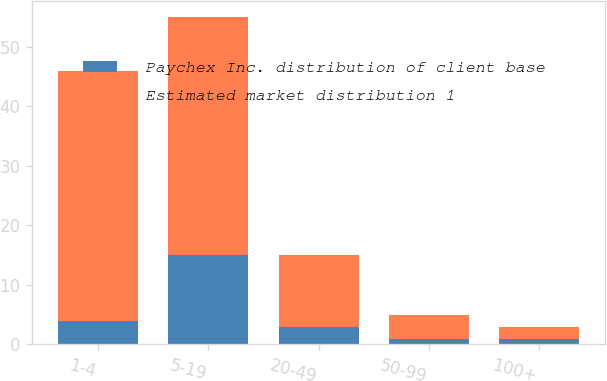<chart> <loc_0><loc_0><loc_500><loc_500><stacked_bar_chart><ecel><fcel>1-4<fcel>5-19<fcel>20-49<fcel>50-99<fcel>100+<nl><fcel>Paychex Inc. distribution of client base<fcel>4<fcel>15<fcel>3<fcel>1<fcel>1<nl><fcel>Estimated market distribution 1<fcel>42<fcel>40<fcel>12<fcel>4<fcel>2<nl></chart> 